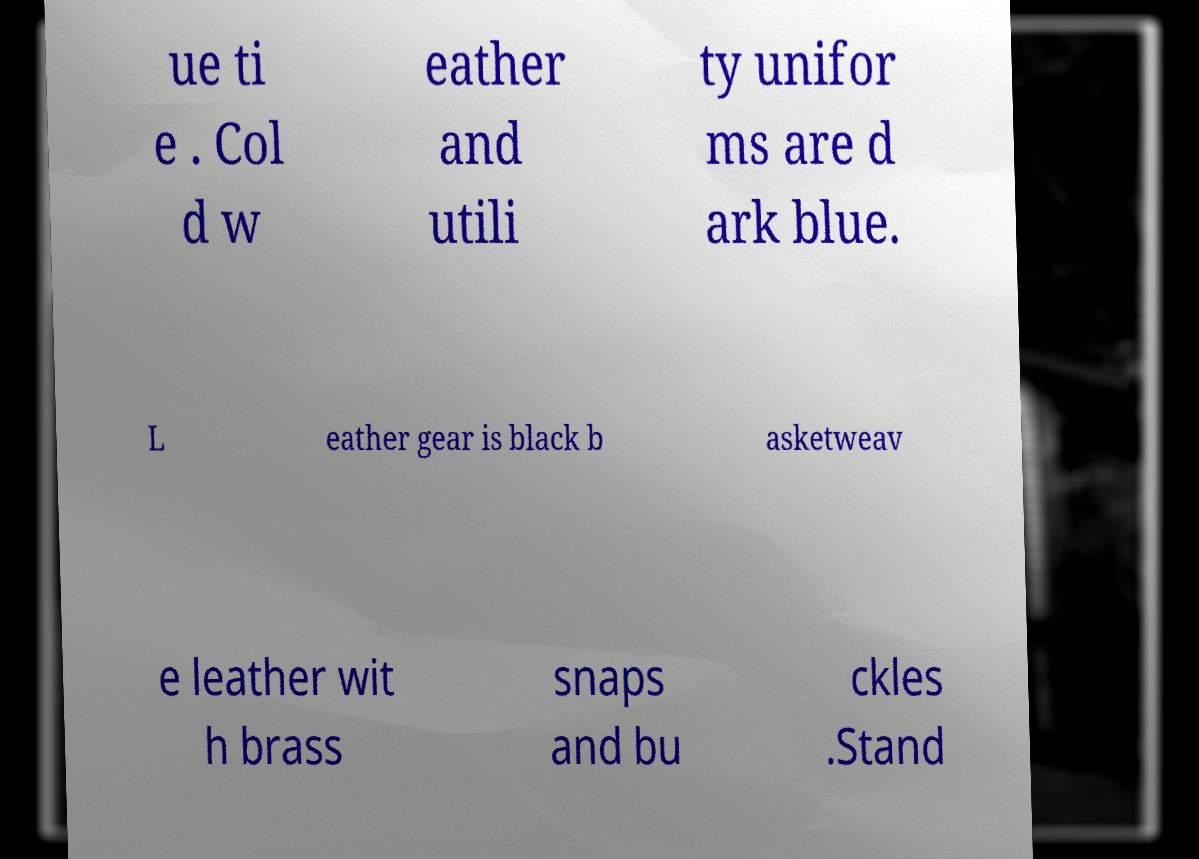Could you assist in decoding the text presented in this image and type it out clearly? ue ti e . Col d w eather and utili ty unifor ms are d ark blue. L eather gear is black b asketweav e leather wit h brass snaps and bu ckles .Stand 